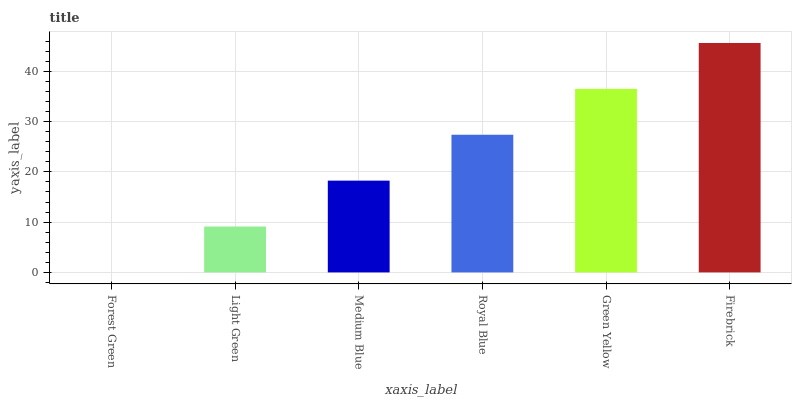Is Forest Green the minimum?
Answer yes or no. Yes. Is Firebrick the maximum?
Answer yes or no. Yes. Is Light Green the minimum?
Answer yes or no. No. Is Light Green the maximum?
Answer yes or no. No. Is Light Green greater than Forest Green?
Answer yes or no. Yes. Is Forest Green less than Light Green?
Answer yes or no. Yes. Is Forest Green greater than Light Green?
Answer yes or no. No. Is Light Green less than Forest Green?
Answer yes or no. No. Is Royal Blue the high median?
Answer yes or no. Yes. Is Medium Blue the low median?
Answer yes or no. Yes. Is Light Green the high median?
Answer yes or no. No. Is Green Yellow the low median?
Answer yes or no. No. 